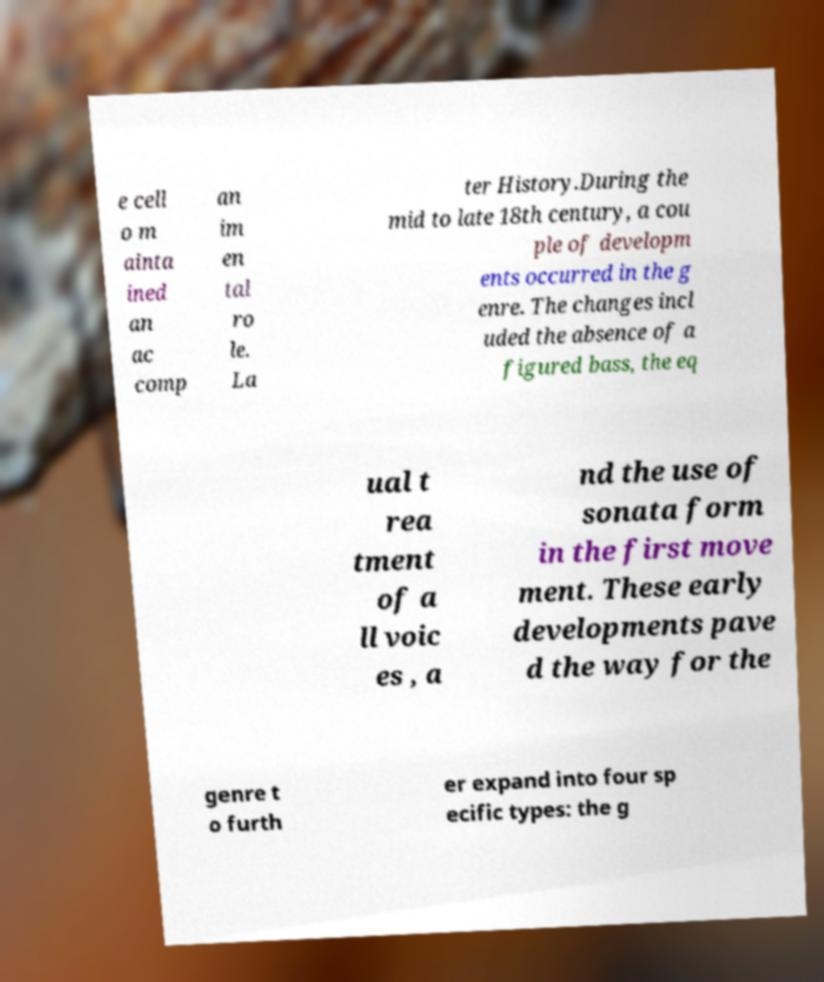For documentation purposes, I need the text within this image transcribed. Could you provide that? e cell o m ainta ined an ac comp an im en tal ro le. La ter History.During the mid to late 18th century, a cou ple of developm ents occurred in the g enre. The changes incl uded the absence of a figured bass, the eq ual t rea tment of a ll voic es , a nd the use of sonata form in the first move ment. These early developments pave d the way for the genre t o furth er expand into four sp ecific types: the g 